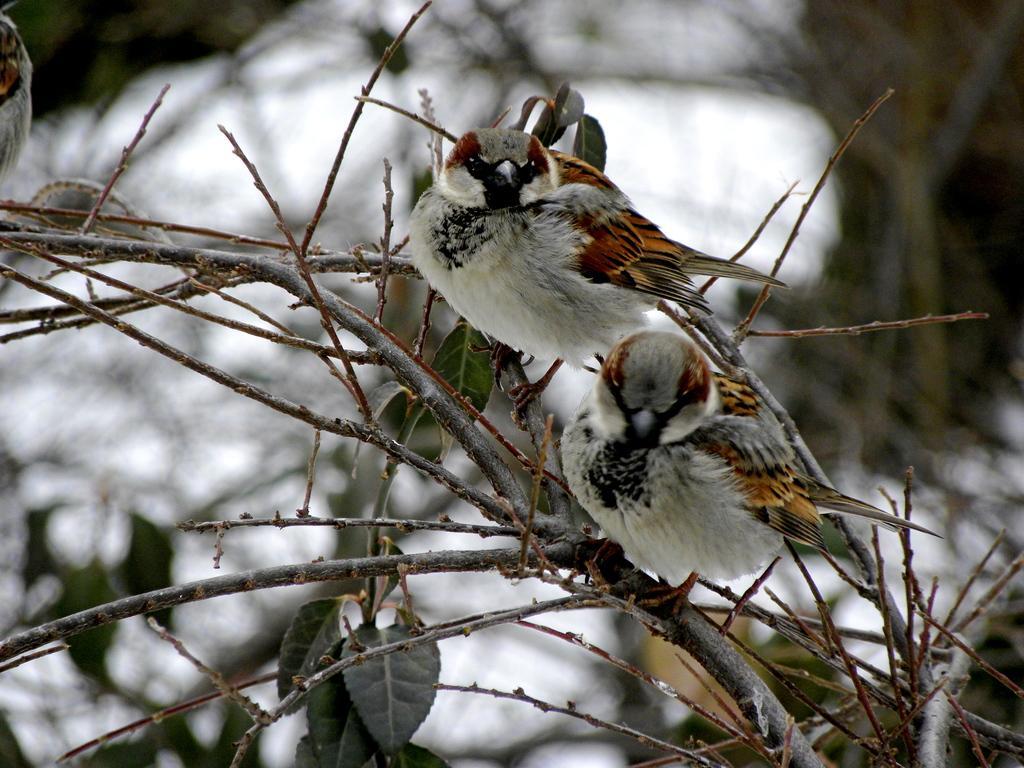In one or two sentences, can you explain what this image depicts? In this picture I can see there are sparrows and there are sitting on a tree and in the backdrop I can see there is snow on the floor. 